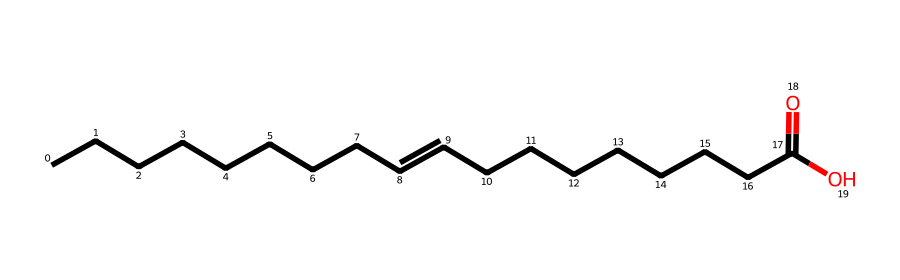What is the basic structure of this natural surfactant? The chemical has a long hydrocarbon chain with a carboxylic acid functional group at one end, characteristic of natural surfactants.
Answer: long hydrocarbon chain with a carboxylic acid How many carbon atoms are present in this molecular structure? By counting the carbon atoms on the chain and including the one in the carboxylic group, there are a total of 18 carbon atoms.
Answer: 18 What functional group is present in this surfactant molecule? The molecule contains a carboxylic acid functional group (–COOH), recognizable by the presence of a carbon double-bonded to an oxygen and bonded to a hydroxyl group.
Answer: carboxylic acid Does this natural surfactant contain any double bonds? Yes, there are two double bonds in the hydrocarbon chain, indicated by the "=" signs in the SMILES structure.
Answer: Yes What property of this surfactant helps in emulsifying oil and water? The presence of the hydrophilic carboxylic acid group at one end of the molecule allows it to interact with water, while the hydrophobic hydrocarbon portion interacts with oils, facilitating emulsification.
Answer: amphiphilic property How might this natural surfactant affect hair's moisture content? The carboxylic acid group can help to lower the surface tension of water, aiding in moisture retention and creating a barrier that helps prevent water loss in hair.
Answer: moisture retention What is the significance of the unsaturation in this surfactant's structure? The unsaturation (double bonds) in the hydrocarbon chains can provide flexibility to the molecule, affecting its ability to form micelles and modify surface activity properties.
Answer: flexibility 